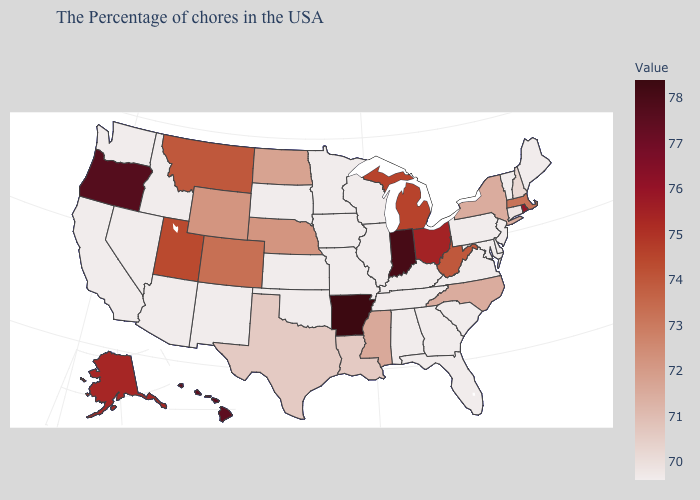Which states have the lowest value in the West?
Write a very short answer. New Mexico, Arizona, Idaho, Nevada, California, Washington. Among the states that border Arizona , does California have the lowest value?
Answer briefly. Yes. Which states have the highest value in the USA?
Quick response, please. Arkansas. Does the map have missing data?
Keep it brief. No. Among the states that border Rhode Island , which have the highest value?
Answer briefly. Massachusetts. Does Arkansas have the highest value in the South?
Give a very brief answer. Yes. Which states hav the highest value in the West?
Short answer required. Oregon. 